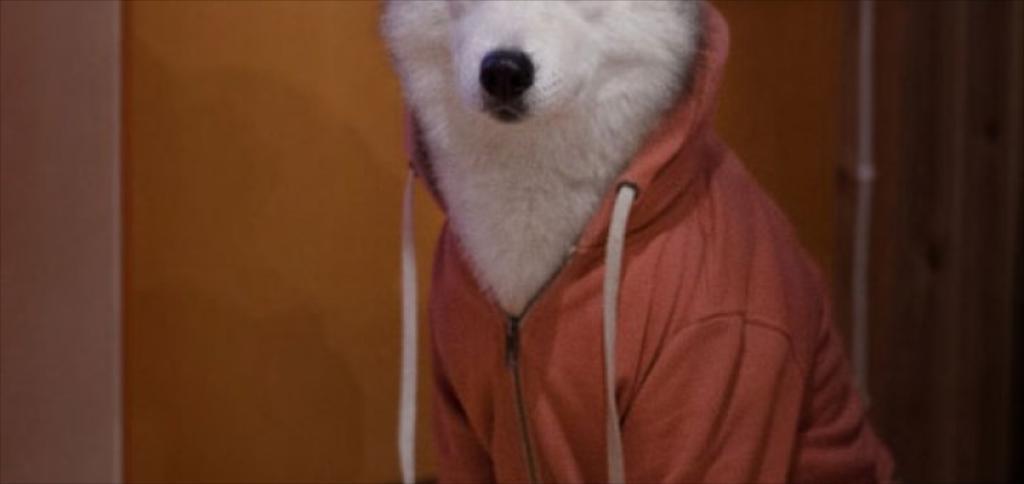Could you give a brief overview of what you see in this image? In this picture I can see a white color animal is wearing clothes. In the background I can see a wall. 